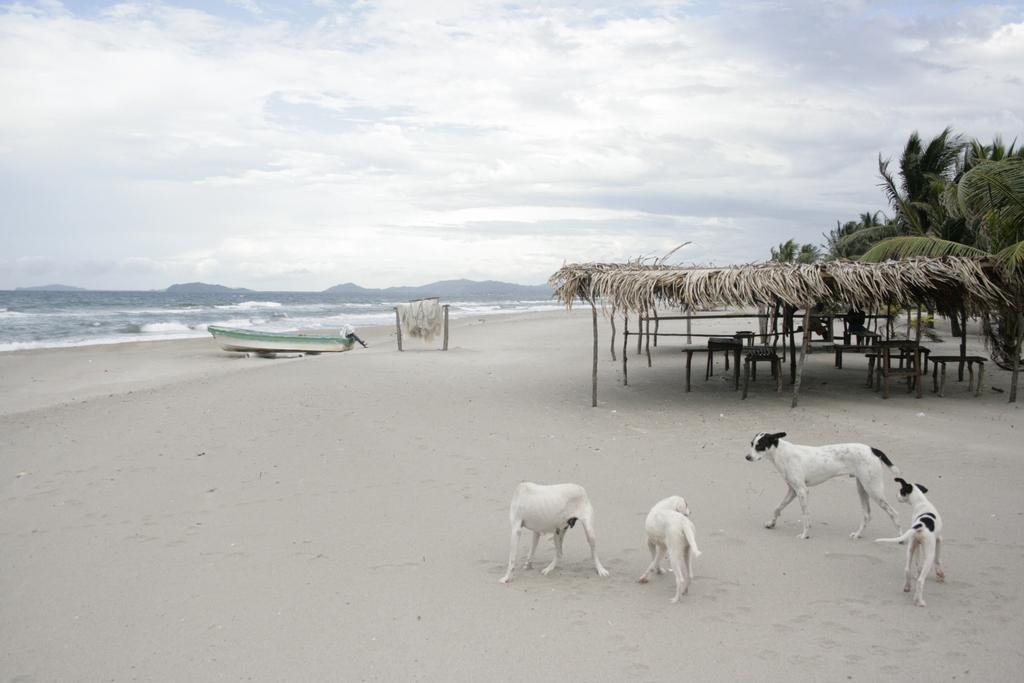Describe this image in one or two sentences. In this image we can see dogs are standing on the sand and a dog is walking. In the background there are few persons sitting on a platform under a roof and we can see tables on the same and there are wooden poles. In the background there are trees, water, boat and an object on the sand, mountains and clouds in the sky. 